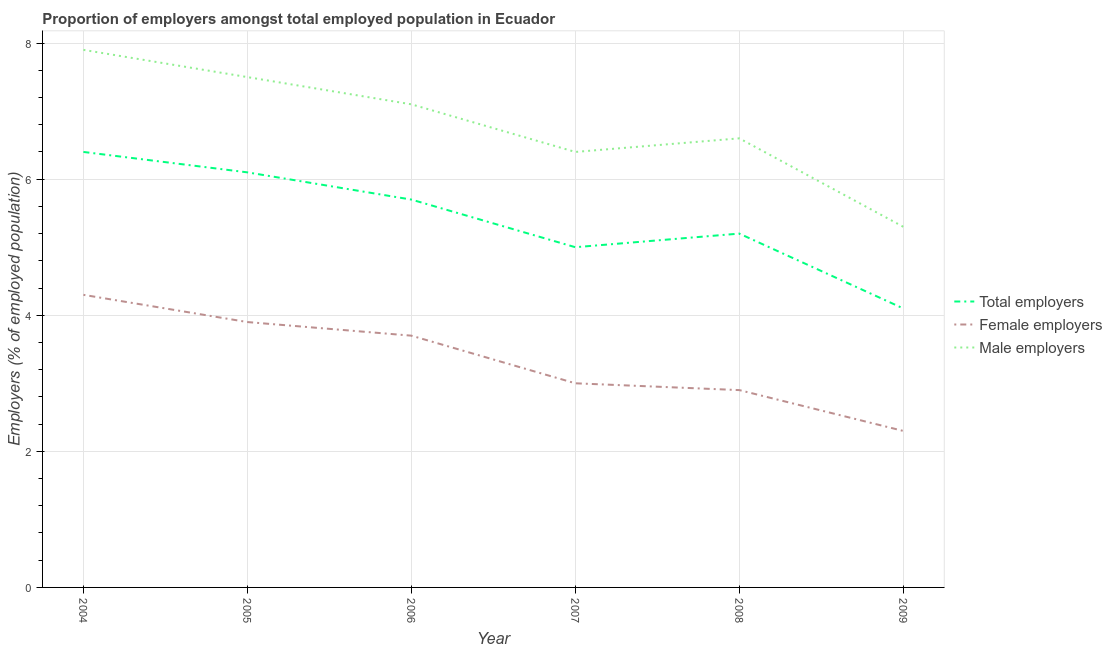How many different coloured lines are there?
Ensure brevity in your answer.  3. Is the number of lines equal to the number of legend labels?
Provide a short and direct response. Yes. What is the percentage of female employers in 2004?
Offer a terse response. 4.3. Across all years, what is the maximum percentage of total employers?
Your answer should be compact. 6.4. Across all years, what is the minimum percentage of total employers?
Offer a terse response. 4.1. What is the total percentage of total employers in the graph?
Offer a very short reply. 32.5. What is the difference between the percentage of male employers in 2005 and that in 2006?
Make the answer very short. 0.4. What is the difference between the percentage of total employers in 2004 and the percentage of male employers in 2005?
Keep it short and to the point. -1.1. What is the average percentage of total employers per year?
Your answer should be compact. 5.42. In the year 2006, what is the difference between the percentage of female employers and percentage of male employers?
Offer a terse response. -3.4. What is the ratio of the percentage of male employers in 2006 to that in 2008?
Give a very brief answer. 1.08. Is the percentage of total employers in 2004 less than that in 2007?
Make the answer very short. No. What is the difference between the highest and the second highest percentage of total employers?
Your answer should be very brief. 0.3. What is the difference between the highest and the lowest percentage of male employers?
Keep it short and to the point. 2.6. In how many years, is the percentage of total employers greater than the average percentage of total employers taken over all years?
Your response must be concise. 3. Is the sum of the percentage of female employers in 2004 and 2005 greater than the maximum percentage of total employers across all years?
Ensure brevity in your answer.  Yes. Is it the case that in every year, the sum of the percentage of total employers and percentage of female employers is greater than the percentage of male employers?
Offer a very short reply. Yes. Is the percentage of total employers strictly greater than the percentage of female employers over the years?
Ensure brevity in your answer.  Yes. Is the percentage of total employers strictly less than the percentage of male employers over the years?
Give a very brief answer. Yes. Does the graph contain any zero values?
Provide a short and direct response. No. Where does the legend appear in the graph?
Ensure brevity in your answer.  Center right. How many legend labels are there?
Provide a succinct answer. 3. What is the title of the graph?
Offer a very short reply. Proportion of employers amongst total employed population in Ecuador. What is the label or title of the X-axis?
Give a very brief answer. Year. What is the label or title of the Y-axis?
Offer a terse response. Employers (% of employed population). What is the Employers (% of employed population) in Total employers in 2004?
Provide a short and direct response. 6.4. What is the Employers (% of employed population) in Female employers in 2004?
Make the answer very short. 4.3. What is the Employers (% of employed population) in Male employers in 2004?
Offer a terse response. 7.9. What is the Employers (% of employed population) of Total employers in 2005?
Your answer should be compact. 6.1. What is the Employers (% of employed population) of Female employers in 2005?
Your response must be concise. 3.9. What is the Employers (% of employed population) of Total employers in 2006?
Give a very brief answer. 5.7. What is the Employers (% of employed population) of Female employers in 2006?
Ensure brevity in your answer.  3.7. What is the Employers (% of employed population) in Male employers in 2006?
Ensure brevity in your answer.  7.1. What is the Employers (% of employed population) in Total employers in 2007?
Ensure brevity in your answer.  5. What is the Employers (% of employed population) of Female employers in 2007?
Provide a short and direct response. 3. What is the Employers (% of employed population) in Male employers in 2007?
Provide a short and direct response. 6.4. What is the Employers (% of employed population) in Total employers in 2008?
Offer a very short reply. 5.2. What is the Employers (% of employed population) of Female employers in 2008?
Your answer should be compact. 2.9. What is the Employers (% of employed population) of Male employers in 2008?
Ensure brevity in your answer.  6.6. What is the Employers (% of employed population) in Total employers in 2009?
Provide a succinct answer. 4.1. What is the Employers (% of employed population) of Female employers in 2009?
Ensure brevity in your answer.  2.3. What is the Employers (% of employed population) of Male employers in 2009?
Give a very brief answer. 5.3. Across all years, what is the maximum Employers (% of employed population) of Total employers?
Keep it short and to the point. 6.4. Across all years, what is the maximum Employers (% of employed population) of Female employers?
Provide a succinct answer. 4.3. Across all years, what is the maximum Employers (% of employed population) in Male employers?
Keep it short and to the point. 7.9. Across all years, what is the minimum Employers (% of employed population) in Total employers?
Your answer should be very brief. 4.1. Across all years, what is the minimum Employers (% of employed population) of Female employers?
Your response must be concise. 2.3. Across all years, what is the minimum Employers (% of employed population) in Male employers?
Offer a terse response. 5.3. What is the total Employers (% of employed population) in Total employers in the graph?
Provide a short and direct response. 32.5. What is the total Employers (% of employed population) of Female employers in the graph?
Make the answer very short. 20.1. What is the total Employers (% of employed population) in Male employers in the graph?
Your answer should be compact. 40.8. What is the difference between the Employers (% of employed population) of Total employers in 2004 and that in 2005?
Make the answer very short. 0.3. What is the difference between the Employers (% of employed population) in Male employers in 2004 and that in 2005?
Ensure brevity in your answer.  0.4. What is the difference between the Employers (% of employed population) of Total employers in 2004 and that in 2006?
Give a very brief answer. 0.7. What is the difference between the Employers (% of employed population) in Female employers in 2004 and that in 2006?
Make the answer very short. 0.6. What is the difference between the Employers (% of employed population) in Female employers in 2004 and that in 2007?
Provide a short and direct response. 1.3. What is the difference between the Employers (% of employed population) in Male employers in 2004 and that in 2008?
Make the answer very short. 1.3. What is the difference between the Employers (% of employed population) of Female employers in 2005 and that in 2007?
Keep it short and to the point. 0.9. What is the difference between the Employers (% of employed population) of Male employers in 2005 and that in 2007?
Your answer should be very brief. 1.1. What is the difference between the Employers (% of employed population) of Total employers in 2005 and that in 2008?
Keep it short and to the point. 0.9. What is the difference between the Employers (% of employed population) in Female employers in 2005 and that in 2008?
Your response must be concise. 1. What is the difference between the Employers (% of employed population) of Male employers in 2005 and that in 2008?
Provide a short and direct response. 0.9. What is the difference between the Employers (% of employed population) of Female employers in 2005 and that in 2009?
Give a very brief answer. 1.6. What is the difference between the Employers (% of employed population) of Male employers in 2005 and that in 2009?
Ensure brevity in your answer.  2.2. What is the difference between the Employers (% of employed population) in Female employers in 2006 and that in 2007?
Your response must be concise. 0.7. What is the difference between the Employers (% of employed population) in Total employers in 2006 and that in 2008?
Provide a short and direct response. 0.5. What is the difference between the Employers (% of employed population) of Female employers in 2006 and that in 2008?
Provide a succinct answer. 0.8. What is the difference between the Employers (% of employed population) in Male employers in 2006 and that in 2009?
Your answer should be compact. 1.8. What is the difference between the Employers (% of employed population) of Total employers in 2007 and that in 2009?
Your response must be concise. 0.9. What is the difference between the Employers (% of employed population) of Female employers in 2007 and that in 2009?
Make the answer very short. 0.7. What is the difference between the Employers (% of employed population) in Male employers in 2007 and that in 2009?
Offer a terse response. 1.1. What is the difference between the Employers (% of employed population) in Male employers in 2008 and that in 2009?
Your answer should be very brief. 1.3. What is the difference between the Employers (% of employed population) in Total employers in 2004 and the Employers (% of employed population) in Female employers in 2005?
Offer a terse response. 2.5. What is the difference between the Employers (% of employed population) of Total employers in 2004 and the Employers (% of employed population) of Male employers in 2005?
Provide a short and direct response. -1.1. What is the difference between the Employers (% of employed population) in Female employers in 2004 and the Employers (% of employed population) in Male employers in 2005?
Your answer should be very brief. -3.2. What is the difference between the Employers (% of employed population) in Total employers in 2004 and the Employers (% of employed population) in Male employers in 2006?
Your answer should be very brief. -0.7. What is the difference between the Employers (% of employed population) of Total employers in 2004 and the Employers (% of employed population) of Female employers in 2007?
Offer a very short reply. 3.4. What is the difference between the Employers (% of employed population) of Total employers in 2004 and the Employers (% of employed population) of Male employers in 2007?
Provide a short and direct response. 0. What is the difference between the Employers (% of employed population) in Total employers in 2004 and the Employers (% of employed population) in Female employers in 2008?
Make the answer very short. 3.5. What is the difference between the Employers (% of employed population) of Female employers in 2004 and the Employers (% of employed population) of Male employers in 2008?
Ensure brevity in your answer.  -2.3. What is the difference between the Employers (% of employed population) of Total employers in 2005 and the Employers (% of employed population) of Female employers in 2006?
Offer a terse response. 2.4. What is the difference between the Employers (% of employed population) of Total employers in 2005 and the Employers (% of employed population) of Female employers in 2007?
Keep it short and to the point. 3.1. What is the difference between the Employers (% of employed population) of Total employers in 2005 and the Employers (% of employed population) of Male employers in 2009?
Make the answer very short. 0.8. What is the difference between the Employers (% of employed population) of Female employers in 2006 and the Employers (% of employed population) of Male employers in 2007?
Your response must be concise. -2.7. What is the difference between the Employers (% of employed population) of Total employers in 2006 and the Employers (% of employed population) of Male employers in 2008?
Your answer should be very brief. -0.9. What is the difference between the Employers (% of employed population) of Total employers in 2007 and the Employers (% of employed population) of Female employers in 2008?
Ensure brevity in your answer.  2.1. What is the difference between the Employers (% of employed population) of Total employers in 2007 and the Employers (% of employed population) of Male employers in 2008?
Ensure brevity in your answer.  -1.6. What is the difference between the Employers (% of employed population) in Total employers in 2007 and the Employers (% of employed population) in Female employers in 2009?
Provide a short and direct response. 2.7. What is the difference between the Employers (% of employed population) in Total employers in 2008 and the Employers (% of employed population) in Male employers in 2009?
Keep it short and to the point. -0.1. What is the difference between the Employers (% of employed population) of Female employers in 2008 and the Employers (% of employed population) of Male employers in 2009?
Your answer should be very brief. -2.4. What is the average Employers (% of employed population) in Total employers per year?
Offer a very short reply. 5.42. What is the average Employers (% of employed population) in Female employers per year?
Make the answer very short. 3.35. What is the average Employers (% of employed population) of Male employers per year?
Your answer should be compact. 6.8. In the year 2004, what is the difference between the Employers (% of employed population) of Total employers and Employers (% of employed population) of Male employers?
Your answer should be very brief. -1.5. In the year 2005, what is the difference between the Employers (% of employed population) of Total employers and Employers (% of employed population) of Female employers?
Your answer should be compact. 2.2. In the year 2005, what is the difference between the Employers (% of employed population) in Total employers and Employers (% of employed population) in Male employers?
Provide a succinct answer. -1.4. In the year 2005, what is the difference between the Employers (% of employed population) of Female employers and Employers (% of employed population) of Male employers?
Give a very brief answer. -3.6. In the year 2006, what is the difference between the Employers (% of employed population) of Total employers and Employers (% of employed population) of Male employers?
Your response must be concise. -1.4. In the year 2007, what is the difference between the Employers (% of employed population) in Total employers and Employers (% of employed population) in Male employers?
Provide a succinct answer. -1.4. In the year 2008, what is the difference between the Employers (% of employed population) of Female employers and Employers (% of employed population) of Male employers?
Offer a very short reply. -3.7. In the year 2009, what is the difference between the Employers (% of employed population) in Total employers and Employers (% of employed population) in Female employers?
Offer a terse response. 1.8. What is the ratio of the Employers (% of employed population) of Total employers in 2004 to that in 2005?
Provide a succinct answer. 1.05. What is the ratio of the Employers (% of employed population) of Female employers in 2004 to that in 2005?
Make the answer very short. 1.1. What is the ratio of the Employers (% of employed population) in Male employers in 2004 to that in 2005?
Keep it short and to the point. 1.05. What is the ratio of the Employers (% of employed population) of Total employers in 2004 to that in 2006?
Offer a very short reply. 1.12. What is the ratio of the Employers (% of employed population) in Female employers in 2004 to that in 2006?
Provide a short and direct response. 1.16. What is the ratio of the Employers (% of employed population) of Male employers in 2004 to that in 2006?
Your answer should be very brief. 1.11. What is the ratio of the Employers (% of employed population) of Total employers in 2004 to that in 2007?
Make the answer very short. 1.28. What is the ratio of the Employers (% of employed population) in Female employers in 2004 to that in 2007?
Ensure brevity in your answer.  1.43. What is the ratio of the Employers (% of employed population) of Male employers in 2004 to that in 2007?
Offer a terse response. 1.23. What is the ratio of the Employers (% of employed population) in Total employers in 2004 to that in 2008?
Your answer should be compact. 1.23. What is the ratio of the Employers (% of employed population) of Female employers in 2004 to that in 2008?
Offer a very short reply. 1.48. What is the ratio of the Employers (% of employed population) in Male employers in 2004 to that in 2008?
Provide a short and direct response. 1.2. What is the ratio of the Employers (% of employed population) in Total employers in 2004 to that in 2009?
Offer a very short reply. 1.56. What is the ratio of the Employers (% of employed population) of Female employers in 2004 to that in 2009?
Ensure brevity in your answer.  1.87. What is the ratio of the Employers (% of employed population) of Male employers in 2004 to that in 2009?
Provide a succinct answer. 1.49. What is the ratio of the Employers (% of employed population) in Total employers in 2005 to that in 2006?
Keep it short and to the point. 1.07. What is the ratio of the Employers (% of employed population) in Female employers in 2005 to that in 2006?
Give a very brief answer. 1.05. What is the ratio of the Employers (% of employed population) in Male employers in 2005 to that in 2006?
Offer a very short reply. 1.06. What is the ratio of the Employers (% of employed population) in Total employers in 2005 to that in 2007?
Provide a succinct answer. 1.22. What is the ratio of the Employers (% of employed population) in Female employers in 2005 to that in 2007?
Your answer should be very brief. 1.3. What is the ratio of the Employers (% of employed population) in Male employers in 2005 to that in 2007?
Give a very brief answer. 1.17. What is the ratio of the Employers (% of employed population) in Total employers in 2005 to that in 2008?
Give a very brief answer. 1.17. What is the ratio of the Employers (% of employed population) in Female employers in 2005 to that in 2008?
Make the answer very short. 1.34. What is the ratio of the Employers (% of employed population) in Male employers in 2005 to that in 2008?
Offer a very short reply. 1.14. What is the ratio of the Employers (% of employed population) in Total employers in 2005 to that in 2009?
Make the answer very short. 1.49. What is the ratio of the Employers (% of employed population) of Female employers in 2005 to that in 2009?
Give a very brief answer. 1.7. What is the ratio of the Employers (% of employed population) in Male employers in 2005 to that in 2009?
Keep it short and to the point. 1.42. What is the ratio of the Employers (% of employed population) of Total employers in 2006 to that in 2007?
Provide a short and direct response. 1.14. What is the ratio of the Employers (% of employed population) in Female employers in 2006 to that in 2007?
Ensure brevity in your answer.  1.23. What is the ratio of the Employers (% of employed population) of Male employers in 2006 to that in 2007?
Offer a terse response. 1.11. What is the ratio of the Employers (% of employed population) in Total employers in 2006 to that in 2008?
Provide a succinct answer. 1.1. What is the ratio of the Employers (% of employed population) in Female employers in 2006 to that in 2008?
Your answer should be very brief. 1.28. What is the ratio of the Employers (% of employed population) of Male employers in 2006 to that in 2008?
Your response must be concise. 1.08. What is the ratio of the Employers (% of employed population) of Total employers in 2006 to that in 2009?
Your answer should be compact. 1.39. What is the ratio of the Employers (% of employed population) in Female employers in 2006 to that in 2009?
Make the answer very short. 1.61. What is the ratio of the Employers (% of employed population) in Male employers in 2006 to that in 2009?
Offer a very short reply. 1.34. What is the ratio of the Employers (% of employed population) in Total employers in 2007 to that in 2008?
Offer a terse response. 0.96. What is the ratio of the Employers (% of employed population) of Female employers in 2007 to that in 2008?
Offer a terse response. 1.03. What is the ratio of the Employers (% of employed population) of Male employers in 2007 to that in 2008?
Your answer should be very brief. 0.97. What is the ratio of the Employers (% of employed population) in Total employers in 2007 to that in 2009?
Your answer should be very brief. 1.22. What is the ratio of the Employers (% of employed population) of Female employers in 2007 to that in 2009?
Your response must be concise. 1.3. What is the ratio of the Employers (% of employed population) in Male employers in 2007 to that in 2009?
Your answer should be very brief. 1.21. What is the ratio of the Employers (% of employed population) of Total employers in 2008 to that in 2009?
Your answer should be very brief. 1.27. What is the ratio of the Employers (% of employed population) in Female employers in 2008 to that in 2009?
Offer a terse response. 1.26. What is the ratio of the Employers (% of employed population) of Male employers in 2008 to that in 2009?
Give a very brief answer. 1.25. What is the difference between the highest and the second highest Employers (% of employed population) of Total employers?
Provide a short and direct response. 0.3. 